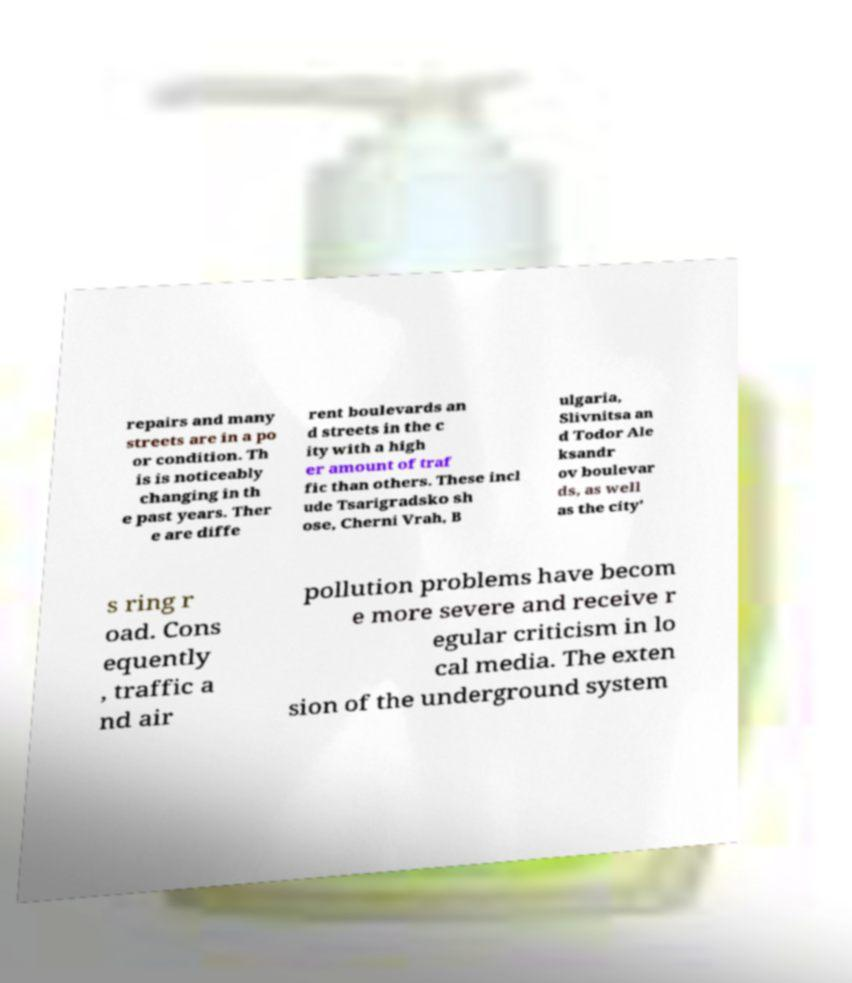I need the written content from this picture converted into text. Can you do that? repairs and many streets are in a po or condition. Th is is noticeably changing in th e past years. Ther e are diffe rent boulevards an d streets in the c ity with a high er amount of traf fic than others. These incl ude Tsarigradsko sh ose, Cherni Vrah, B ulgaria, Slivnitsa an d Todor Ale ksandr ov boulevar ds, as well as the city' s ring r oad. Cons equently , traffic a nd air pollution problems have becom e more severe and receive r egular criticism in lo cal media. The exten sion of the underground system 